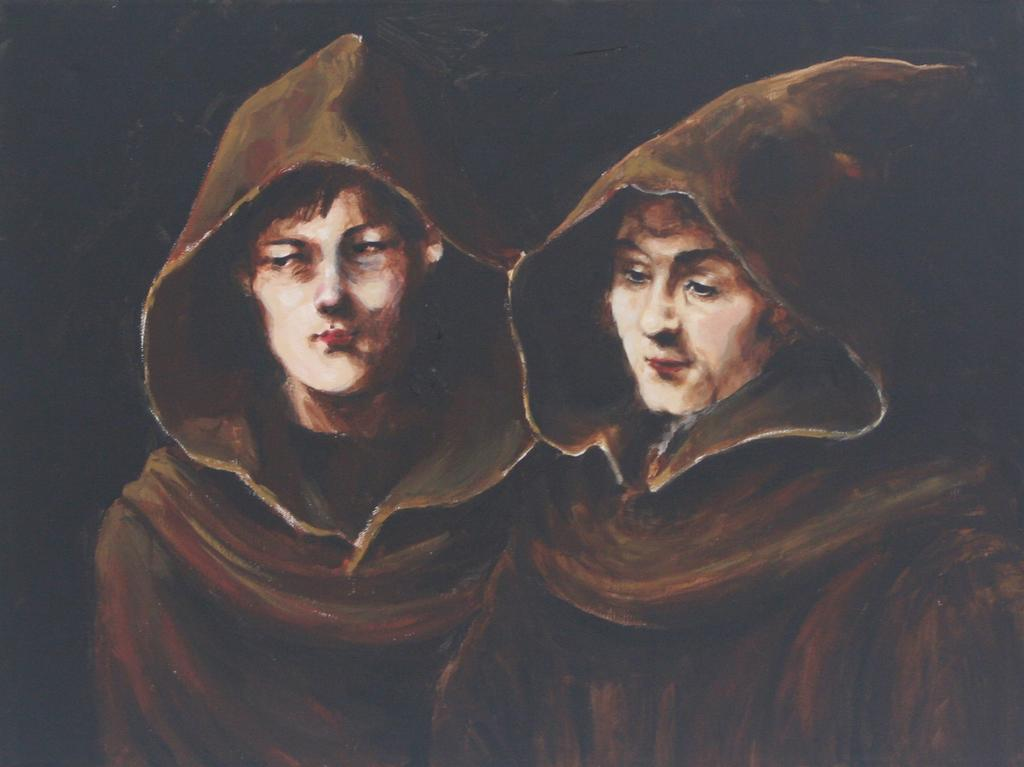What is the main subject of the image? The main subject of the image is a painting. What does the painting depict? The painting depicts a person. What type of truck is visible in the painting? There is no truck present in the painting; it depicts a person. Is the person wearing a ring in the painting? The provided facts do not mention any specific details about the person in the painting, such as the presence of a ring. 